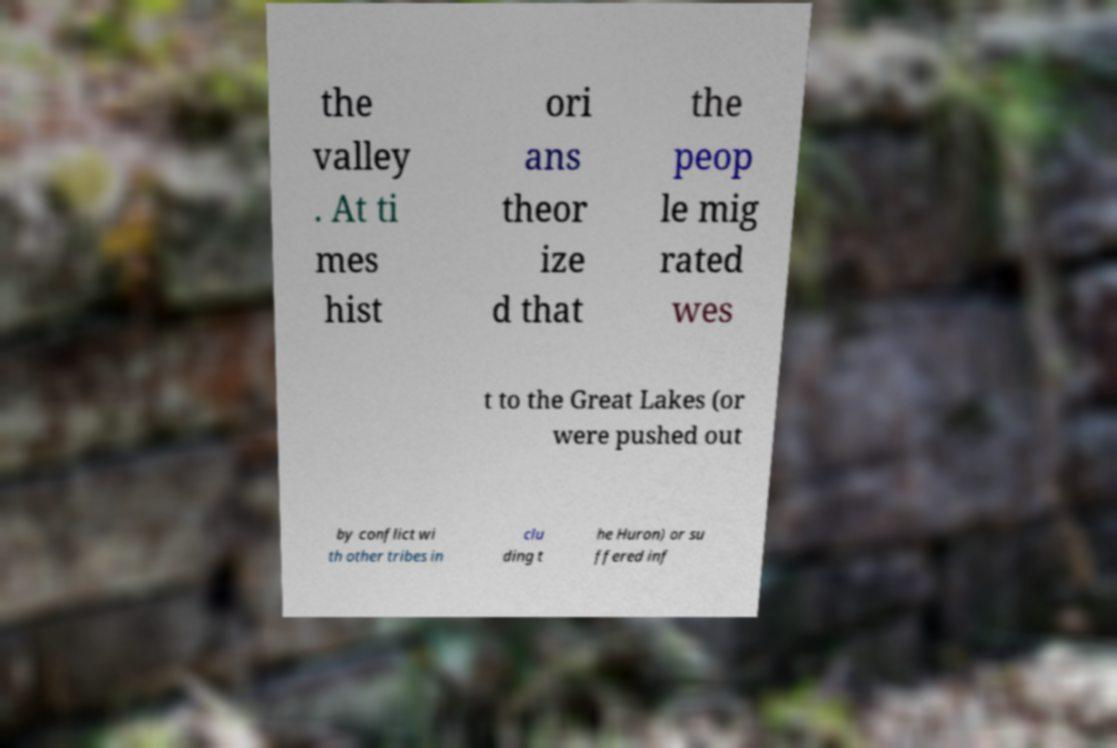Please identify and transcribe the text found in this image. the valley . At ti mes hist ori ans theor ize d that the peop le mig rated wes t to the Great Lakes (or were pushed out by conflict wi th other tribes in clu ding t he Huron) or su ffered inf 